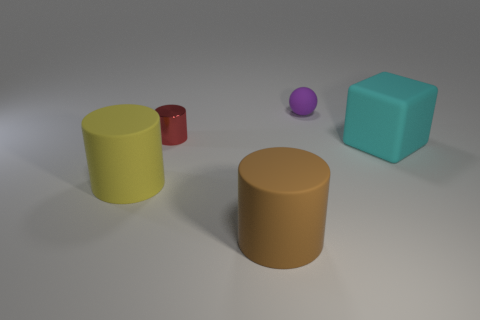Add 5 cylinders. How many objects exist? 10 Subtract all balls. How many objects are left? 4 Add 5 cyan matte things. How many cyan matte things exist? 6 Subtract 0 yellow cubes. How many objects are left? 5 Subtract all large green cylinders. Subtract all small red cylinders. How many objects are left? 4 Add 5 tiny red things. How many tiny red things are left? 6 